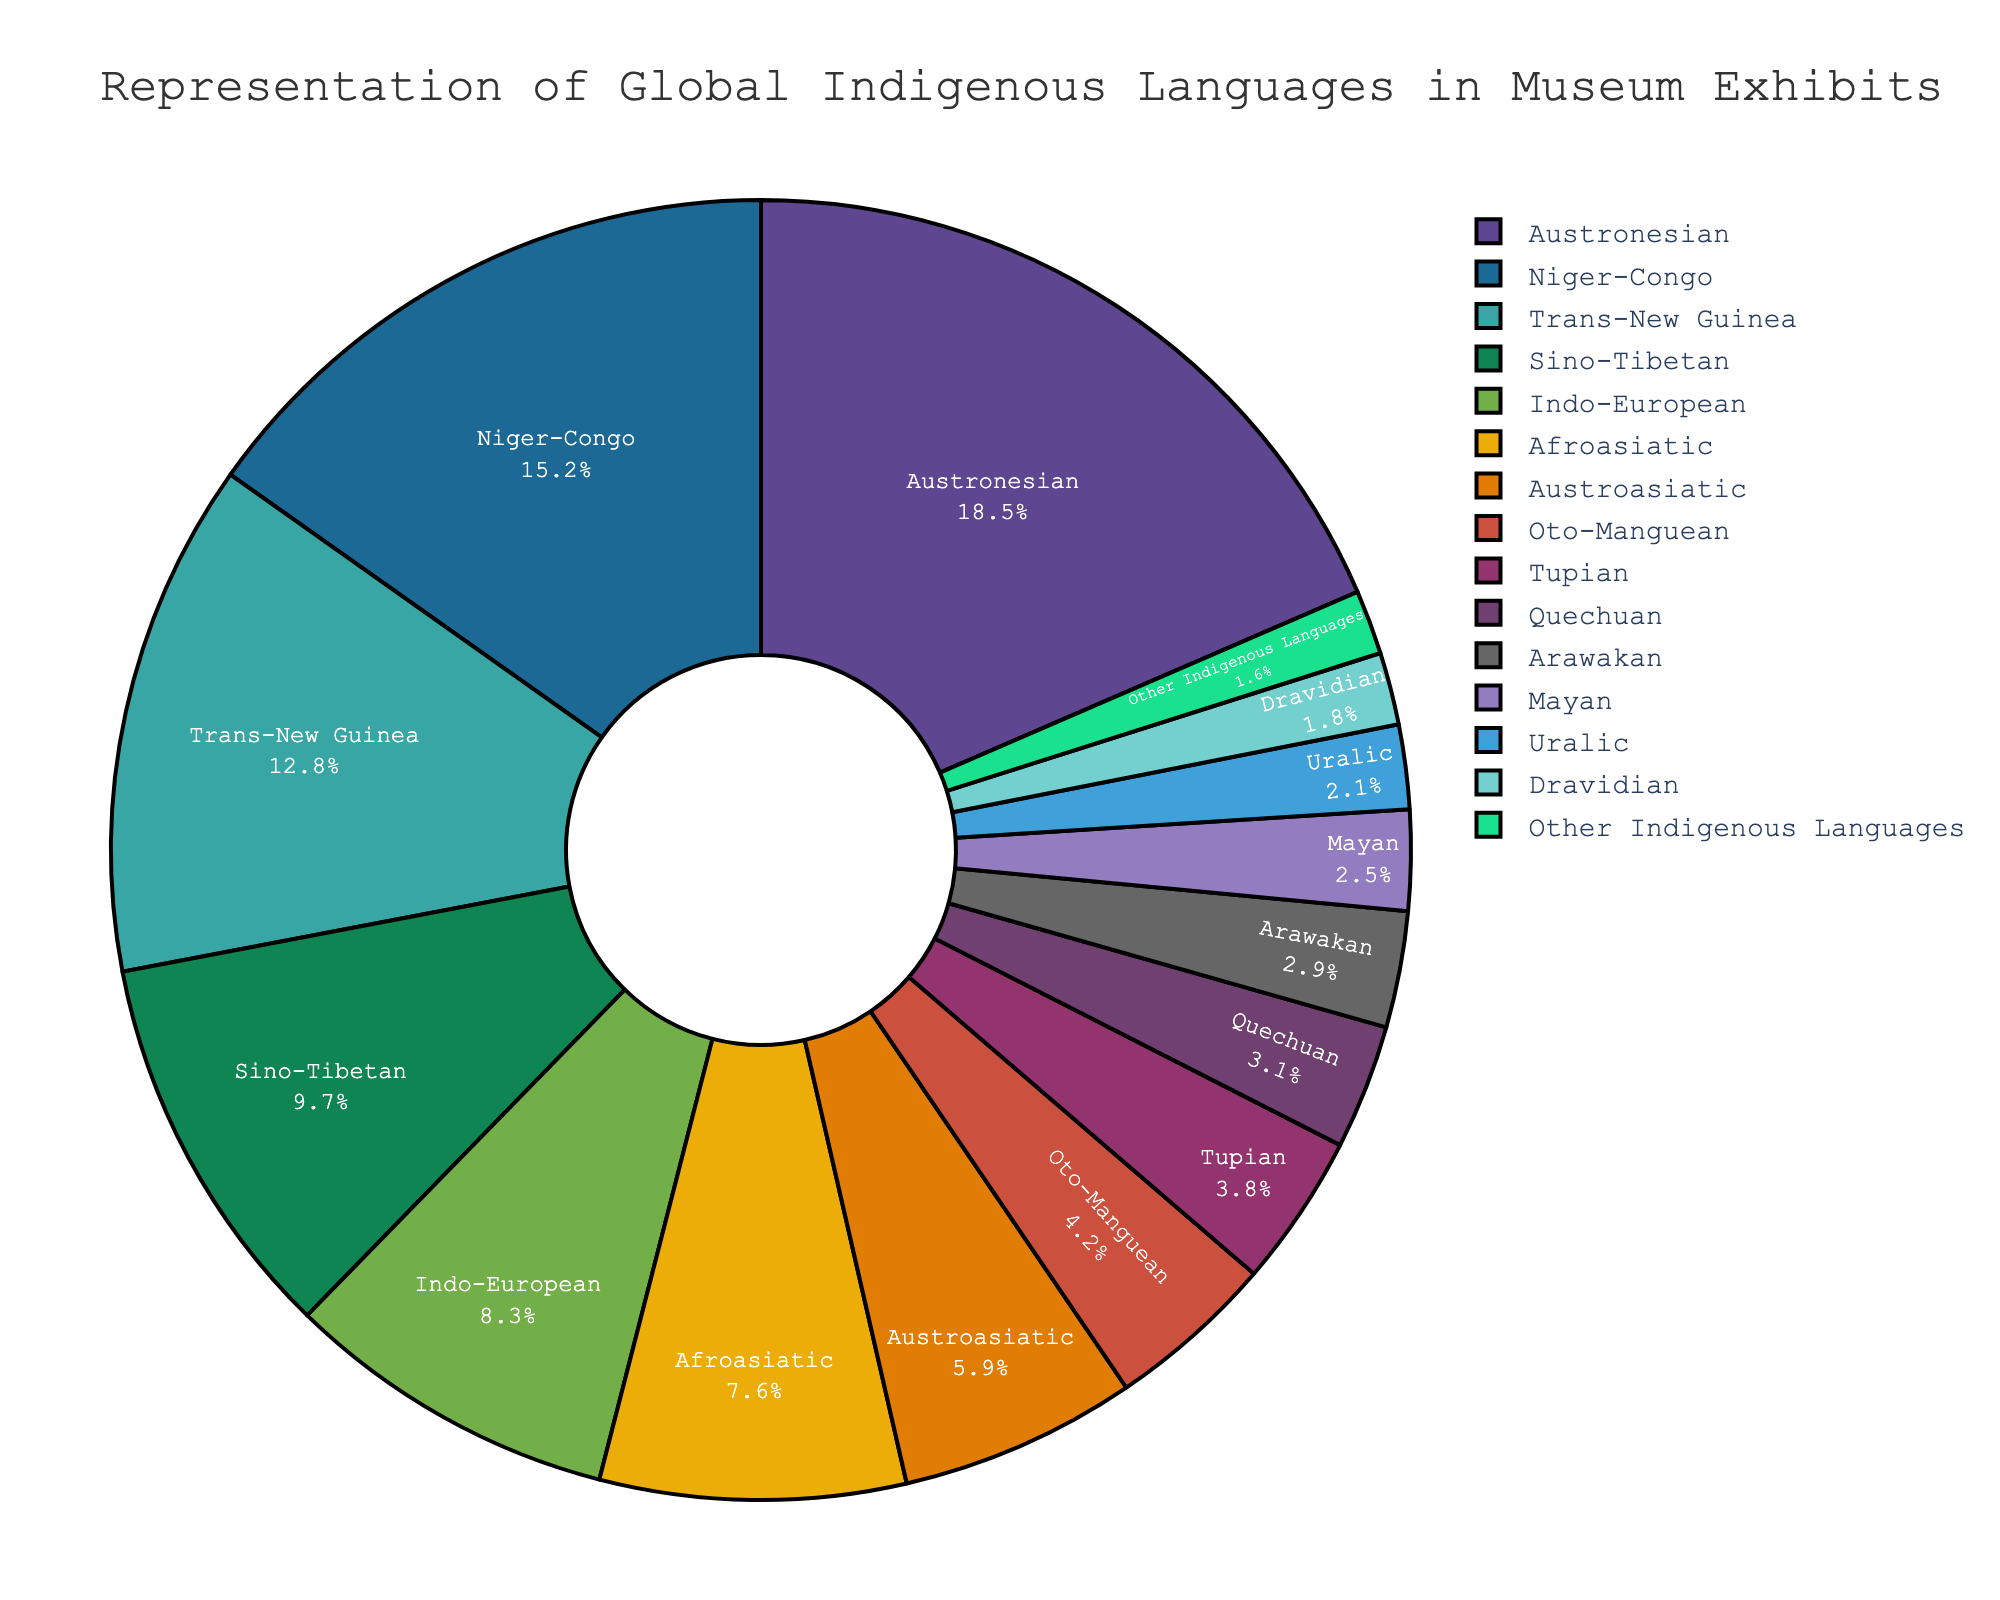What is the most represented language family in museum exhibits? The largest section in the pie chart, colored distinctly, represents 18.5% for the Austronesian language family, making it the most represented.
Answer: Austronesian Which language family has a 3.1% representation in museum exhibits? The slice labeled "Quechuan" indicates that it comprises 3.1% of the museum exhibits.
Answer: Quechuan What is the total percentage of museum exhibits representing the Afroasiatic and Dravidian language families combined? The Afroasiatic slice shows 7.6% and the Dravidian slice shows 1.8%. Adding these together, 7.6% + 1.8% = 9.4%.
Answer: 9.4% Which language family has nearly half the representation of the Austronesian family? The Austronesian family represents 18.5%. Half of 18.5% is approximately 9.25%. The Sino-Tibetan family has 9.7%, which is close to half.
Answer: Sino-Tibetan What is the difference in the percentage representation between the Niger-Congo and Trans-New Guinea language families? The pie chart shows Niger-Congo at 15.2% and Trans-New Guinea at 12.8%. Subtracting these gives 15.2% - 12.8% = 2.4%.
Answer: 2.4% How much more represented is the Indo-European family compared to the Oto-Manguean family? The Indo-European family represents 8.3%, while the Oto-Manguean family represents 4.2%. Subtracting these gives 8.3% - 4.2% = 4.1%.
Answer: 4.1% What is the total percentage of museum exhibits that represent the 'Other Indigenous Languages' category? The pie chart has a slice labeled 'Other Indigenous Languages' with a percentage of 1.6%.
Answer: 1.6% Which language family is depicted in a comparatively smaller section than the Mayan family? The Mayan family shows 2.5%. Only the Uralic (2.1%), Dravidian (1.8%), and 'Other Indigenous Languages' (1.6%) sections are smaller. The 'Other Indigenous Languages' family is indeed smaller.
Answer: Other Indigenous Languages Calculate the collective percentage representation of all language families below 5%. Adding the percentages for Oto-Manguean (4.2%), Tupian (3.8%), Quechuan (3.1%), Arawakan (2.9%), Mayan (2.5%), Uralic (2.1%), Dravidian (1.8%), and Other Indigenous Languages (1.6%) gives:
(4.2% + 3.8% + 3.1% + 2.9% + 2.5% + 2.1% + 1.8% + 1.6%) = 21.9%.
Answer: 21.9% Which language family has a representation that is closer to the average percentage across all families? To find the average, sum all percentages and divide by the number of language families. The total is 100%. There are 15 entries:
100% / 15 = 6.67%. The Austroasiatic family at 5.9% is closest to this average.
Answer: Austroasiatic 